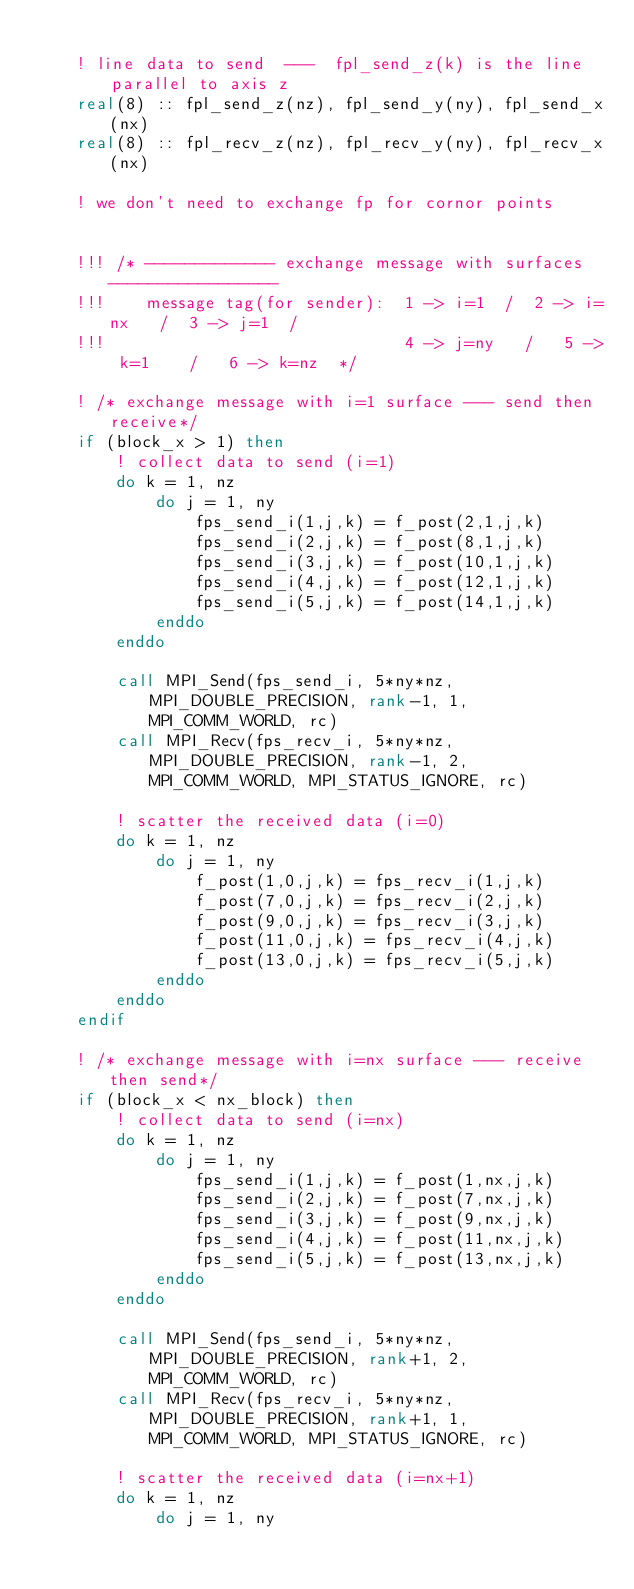<code> <loc_0><loc_0><loc_500><loc_500><_FORTRAN_>
    ! line data to send  ---  fpl_send_z(k) is the line parallel to axis z
    real(8) :: fpl_send_z(nz), fpl_send_y(ny), fpl_send_x(nx)
    real(8) :: fpl_recv_z(nz), fpl_recv_y(ny), fpl_recv_x(nx)

    ! we don't need to exchange fp for cornor points


    !!! /* ------------- exchange message with surfaces ----------------- 
    !!!    message tag(for sender):  1 -> i=1  /  2 -> i=nx   /  3 -> j=1  /
    !!!                              4 -> j=ny   /   5 -> k=1    /   6 -> k=nz  */

    ! /* exchange message with i=1 surface --- send then receive*/
    if (block_x > 1) then
        ! collect data to send (i=1)
        do k = 1, nz
            do j = 1, ny
                fps_send_i(1,j,k) = f_post(2,1,j,k)
                fps_send_i(2,j,k) = f_post(8,1,j,k)
                fps_send_i(3,j,k) = f_post(10,1,j,k)
                fps_send_i(4,j,k) = f_post(12,1,j,k)
                fps_send_i(5,j,k) = f_post(14,1,j,k)
            enddo
        enddo

        call MPI_Send(fps_send_i, 5*ny*nz, MPI_DOUBLE_PRECISION, rank-1, 1, MPI_COMM_WORLD, rc)
        call MPI_Recv(fps_recv_i, 5*ny*nz, MPI_DOUBLE_PRECISION, rank-1, 2, MPI_COMM_WORLD, MPI_STATUS_IGNORE, rc)
                
        ! scatter the received data (i=0)
        do k = 1, nz 
            do j = 1, ny
                f_post(1,0,j,k) = fps_recv_i(1,j,k)
                f_post(7,0,j,k) = fps_recv_i(2,j,k)
                f_post(9,0,j,k) = fps_recv_i(3,j,k)
                f_post(11,0,j,k) = fps_recv_i(4,j,k)
                f_post(13,0,j,k) = fps_recv_i(5,j,k)
            enddo
        enddo
    endif

    ! /* exchange message with i=nx surface --- receive then send*/
    if (block_x < nx_block) then
        ! collect data to send (i=nx)
        do k = 1, nz
            do j = 1, ny
                fps_send_i(1,j,k) = f_post(1,nx,j,k)
                fps_send_i(2,j,k) = f_post(7,nx,j,k)
                fps_send_i(3,j,k) = f_post(9,nx,j,k)
                fps_send_i(4,j,k) = f_post(11,nx,j,k)
                fps_send_i(5,j,k) = f_post(13,nx,j,k)
            enddo
        enddo

        call MPI_Send(fps_send_i, 5*ny*nz, MPI_DOUBLE_PRECISION, rank+1, 2, MPI_COMM_WORLD, rc)
        call MPI_Recv(fps_recv_i, 5*ny*nz, MPI_DOUBLE_PRECISION, rank+1, 1, MPI_COMM_WORLD, MPI_STATUS_IGNORE, rc)
        
        ! scatter the received data (i=nx+1)
        do k = 1, nz
            do j = 1, ny</code> 